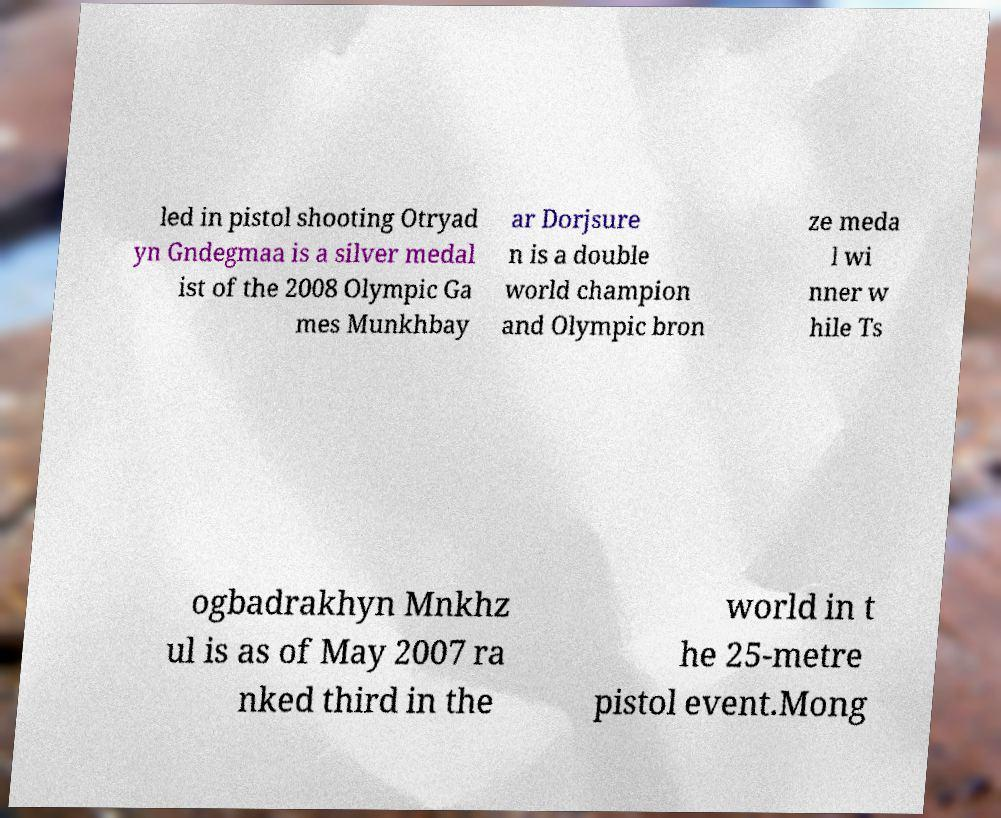Can you read and provide the text displayed in the image?This photo seems to have some interesting text. Can you extract and type it out for me? led in pistol shooting Otryad yn Gndegmaa is a silver medal ist of the 2008 Olympic Ga mes Munkhbay ar Dorjsure n is a double world champion and Olympic bron ze meda l wi nner w hile Ts ogbadrakhyn Mnkhz ul is as of May 2007 ra nked third in the world in t he 25-metre pistol event.Mong 